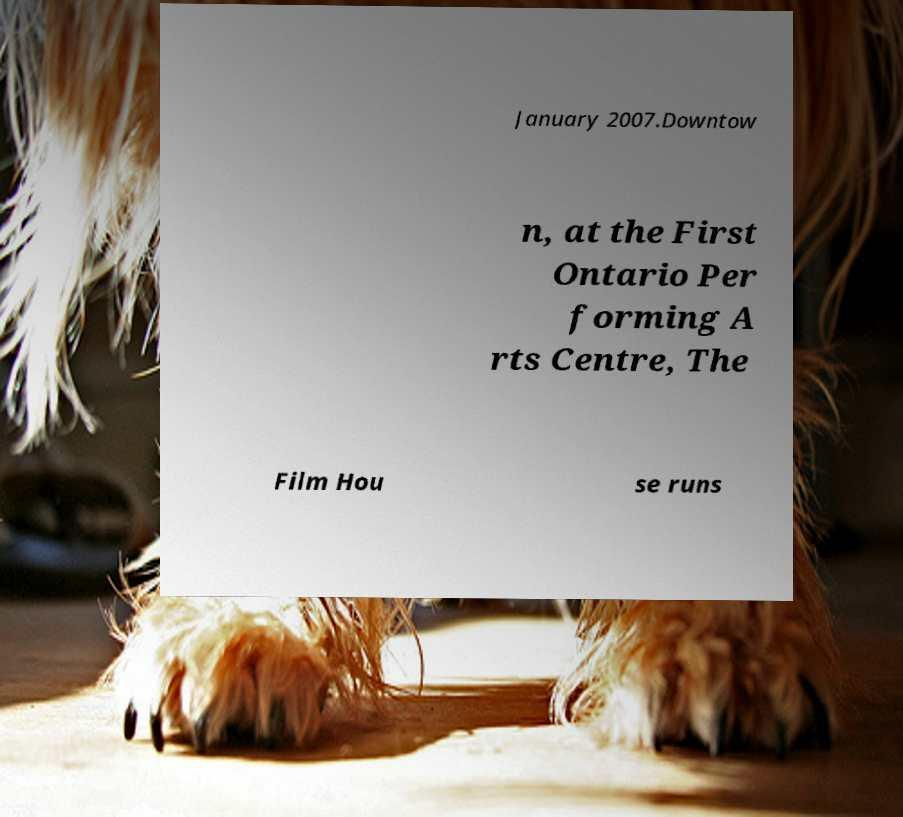Could you extract and type out the text from this image? January 2007.Downtow n, at the First Ontario Per forming A rts Centre, The Film Hou se runs 